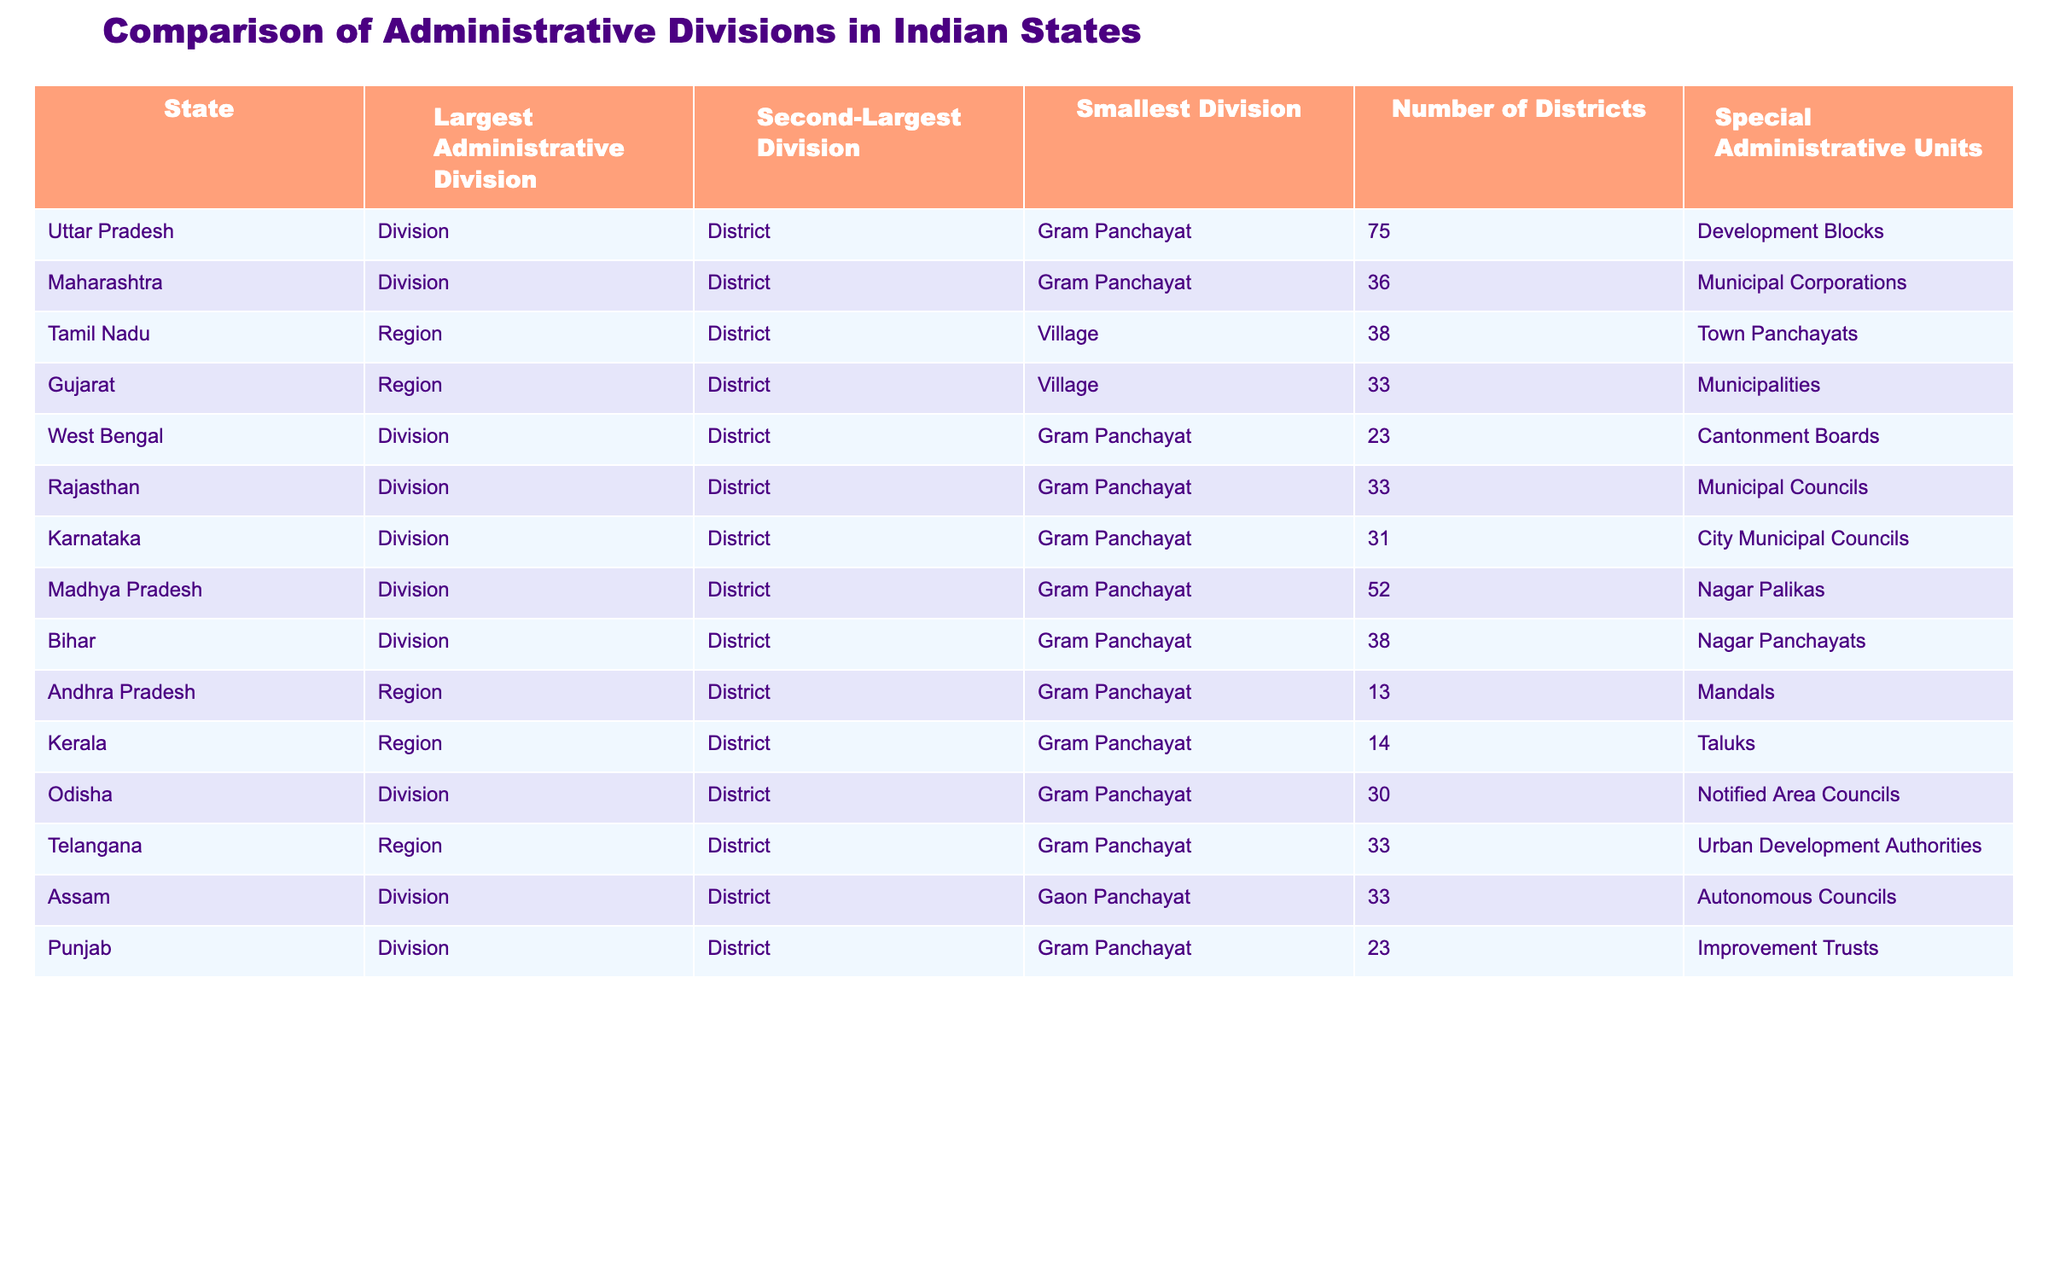What is the largest administrative division in Uttar Pradesh? The table shows that the largest administrative division in Uttar Pradesh is a Division.
Answer: Division How many districts are there in Maharashtra? The table indicates that Maharashtra has 36 districts.
Answer: 36 Is the smallest administrative division in Tamil Nadu a Village? According to the table, the smallest administrative division in Tamil Nadu is indeed a Village.
Answer: Yes What is the number of districts in Bihar compared to West Bengal? Bihar has 38 districts, while West Bengal has 23 districts. This indicates that Bihar has 15 more districts than West Bengal.
Answer: Bihar has 15 more districts Which state has the highest number of districts? Upon examining the table, Uttar Pradesh has the highest number of districts at 75.
Answer: 75 How many states have the largest administrative division classified as a Division? By reviewing the table, the states with Division as the largest administrative division are Uttar Pradesh, Maharashtra, West Bengal, Rajasthan, Karnataka, Madhya Pradesh, Bihar, and Assam, which totals 8 states.
Answer: 8 states What is the average number of districts across all the states listed? First, sum the number of districts: 75 + 36 + 38 + 33 + 23 + 33 + 31 + 52 + 38 + 13 + 14 + 30 + 33 + 23 =  414. There are 14 states in total, thus the average is 414 / 14 ≈ 29.57.
Answer: 29.57 Which state has fewer than 20 districts? The table shows that Andhra Pradesh has only 13 districts, which is fewer than 20.
Answer: Andhra Pradesh Do all states have Gram Panchayat as their smallest administrative division? Looking at the table, not all states have Gram Panchayat; Assam has Gaon Panchayat and Tamil Nadu has Village as the smallest division, indicating that the statement is false.
Answer: No 